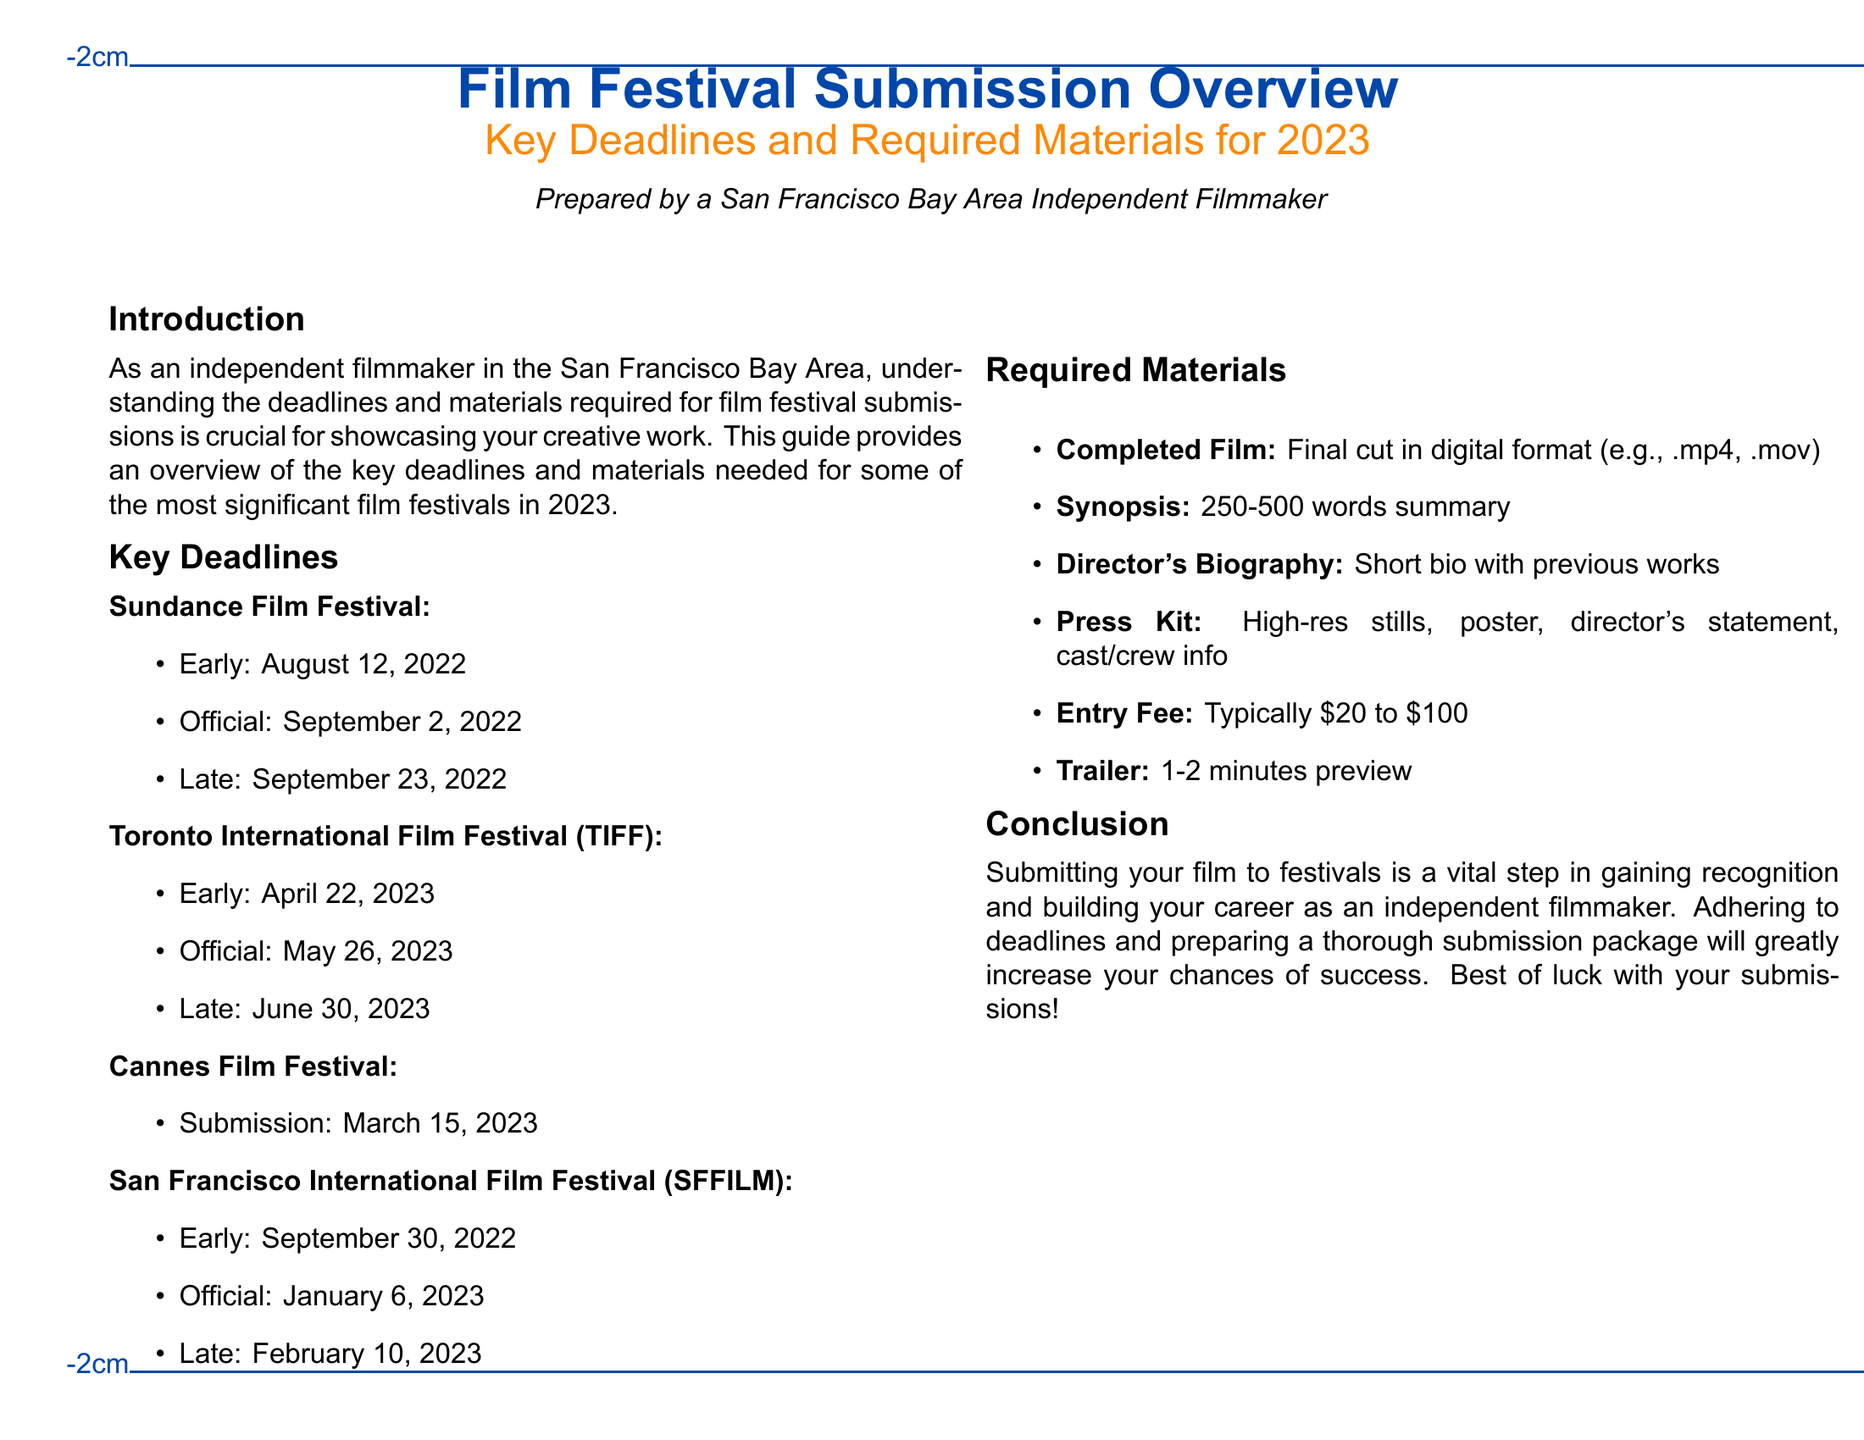What is the early deadline for the Toronto International Film Festival? The early deadline for TIFF is noted in the document under Key Deadlines.
Answer: April 22, 2023 What is required for the entry fee? The entry fee is specified in the Required Materials section of the document, indicating a range.
Answer: Typically $20 to $100 When is the submission deadline for the Cannes Film Festival? The specific submission date for Cannes is provided in the Key Deadlines section.
Answer: March 15, 2023 What type of file format is acceptable for the completed film? The completed film's format is outlined in the Required Materials section indicating the types.
Answer: .mp4, .mov What document type does this overview specifically address? The focus of the document is clearly stated in the title at the beginning.
Answer: Film Festival Submission Overview What do you need to include in the press kit? The Required Materials section details what should be included in the press kit.
Answer: High-res stills, poster, director's statement, cast/crew info What is the official deadline for the San Francisco International Film Festival? The official deadline for SFFILM is found under Key Deadlines in the document.
Answer: January 6, 2023 What is the content length for the director's biography? The expected length for the director's biography is specified in the Required Materials section.
Answer: Short bio with previous works 